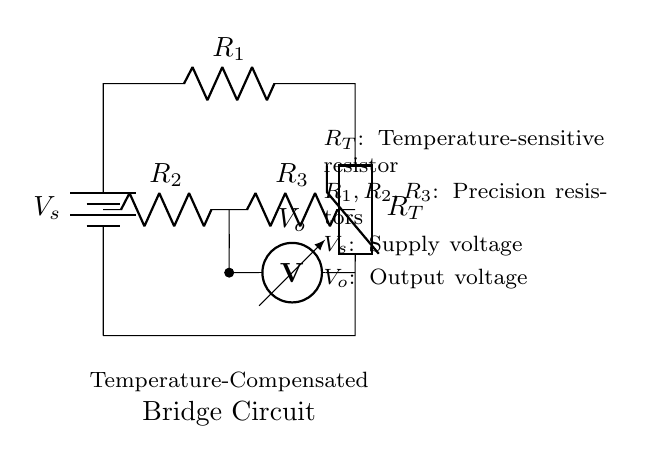What are the components used in this circuit? The components visible include a voltage source, three resistors, and a thermistor. Each plays a role in the temperature compensation and voltage output of the bridge circuit.
Answer: voltage source, three resistors, thermistor What is the purpose of the thermistor in this circuit? The thermistor is a temperature-sensitive resistor that changes its resistance with temperature variations, allowing the circuit to monitor environmental conditions and provide temperature compensation for accurate outputs.
Answer: temperature-sensitive resistor How many resistors are there in total in this bridge circuit? There are three resistors, labeled as R1, R2, and R3 in the diagram. This is important for balancing the bridge and ensuring accurate measurements.
Answer: three What is the output voltage labeled in the circuit? The output voltage is denoted as V_o in the circuit diagram, which is the voltage measured across the specific points in the circuit and is influenced by the balance of the resistors and the thermistor.
Answer: V_o Why is a bridge circuit used for temperature measurement? A bridge circuit, specifically a Wheatstone bridge, allows for high sensitivity and precision in measuring small changes in resistance, which is crucial when monitoring temperature variations with a thermistor in harsh environments.
Answer: precision and sensitivity What is the significance of the supply voltage in this bridge circuit? The supply voltage, labeled V_s, is essential as it provides the necessary power for the circuit to operate and influences the output voltage measured. It needs to be stable for accurate readings.
Answer: V_s 